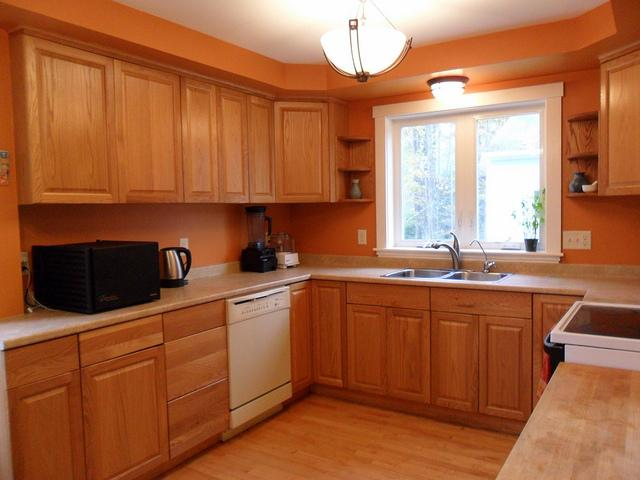What heats the stove for cooking? Please explain your reasoning. electricity. A stove has a flat top. 